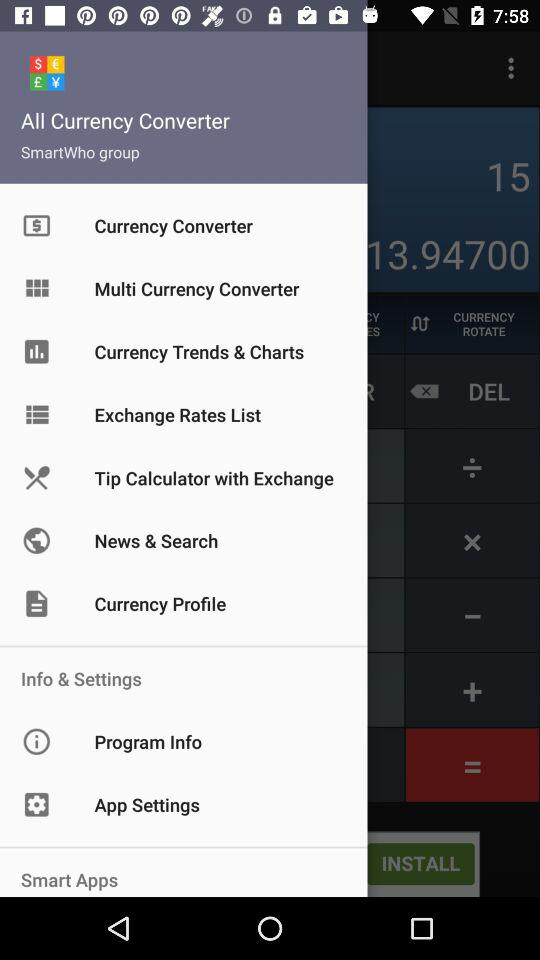What is the application name? The application name is "All Currency Converter". 